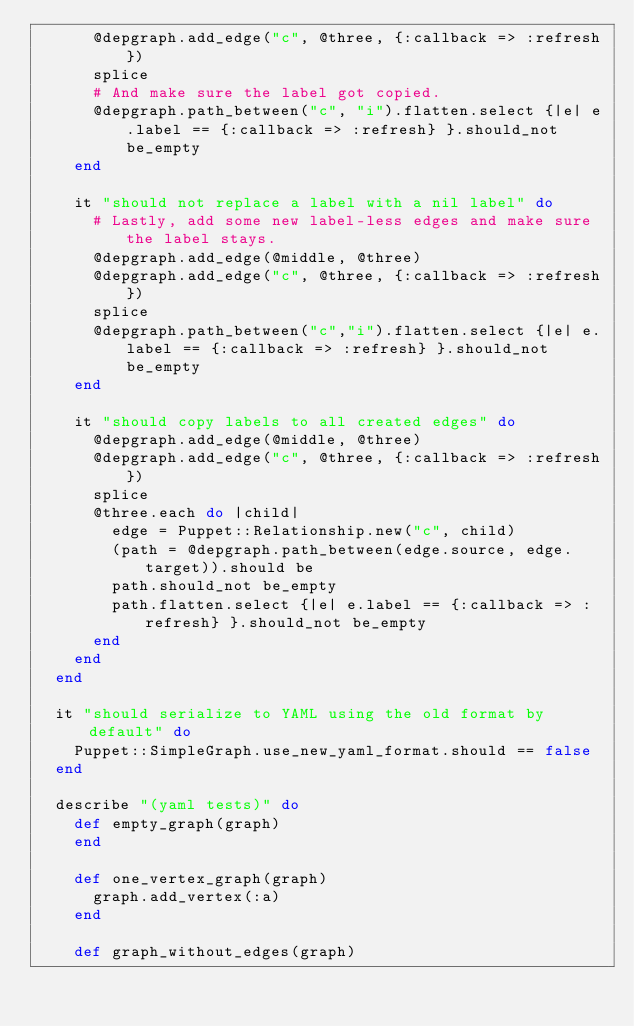<code> <loc_0><loc_0><loc_500><loc_500><_Ruby_>      @depgraph.add_edge("c", @three, {:callback => :refresh})
      splice
      # And make sure the label got copied.
      @depgraph.path_between("c", "i").flatten.select {|e| e.label == {:callback => :refresh} }.should_not be_empty
    end

    it "should not replace a label with a nil label" do
      # Lastly, add some new label-less edges and make sure the label stays.
      @depgraph.add_edge(@middle, @three)
      @depgraph.add_edge("c", @three, {:callback => :refresh})
      splice
      @depgraph.path_between("c","i").flatten.select {|e| e.label == {:callback => :refresh} }.should_not be_empty
    end

    it "should copy labels to all created edges" do
      @depgraph.add_edge(@middle, @three)
      @depgraph.add_edge("c", @three, {:callback => :refresh})
      splice
      @three.each do |child|
        edge = Puppet::Relationship.new("c", child)
        (path = @depgraph.path_between(edge.source, edge.target)).should be
        path.should_not be_empty
        path.flatten.select {|e| e.label == {:callback => :refresh} }.should_not be_empty
      end
    end
  end

  it "should serialize to YAML using the old format by default" do
    Puppet::SimpleGraph.use_new_yaml_format.should == false
  end

  describe "(yaml tests)" do
    def empty_graph(graph)
    end

    def one_vertex_graph(graph)
      graph.add_vertex(:a)
    end

    def graph_without_edges(graph)</code> 